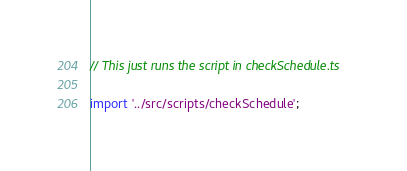<code> <loc_0><loc_0><loc_500><loc_500><_TypeScript_>// This just runs the script in checkSchedule.ts

import '../src/scripts/checkSchedule';
</code> 